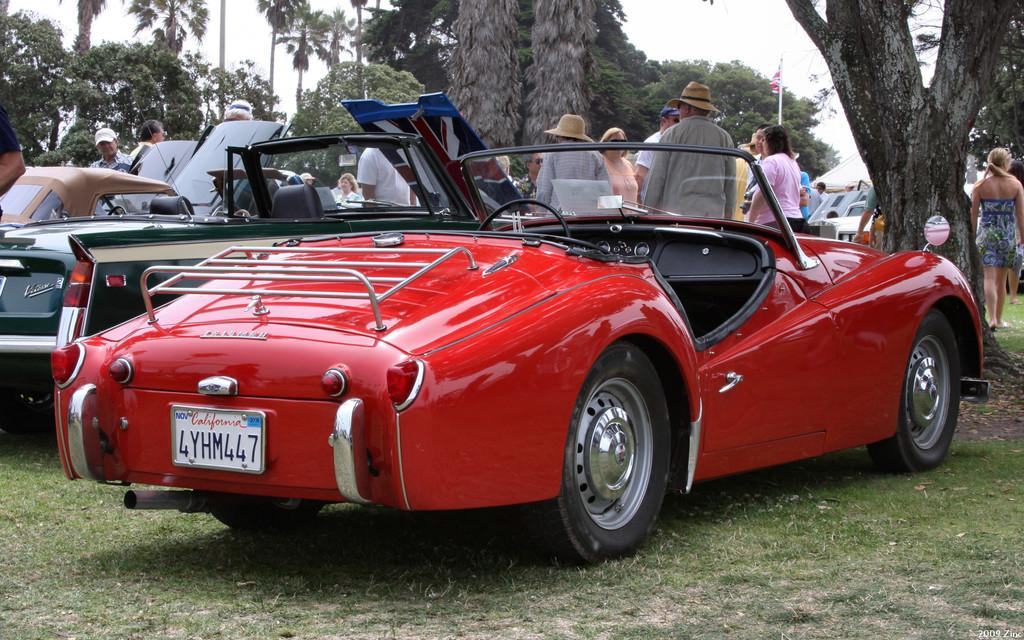What types of objects can be seen in the image? There are vehicles in the image. What else can be seen in the image besides the vehicles? There are people on the ground in the image. What can be seen in the background of the image? There are trees and the sky visible in the background of the image. Can you tell me how many beads are being used for division in the image? There is no reference to beads or division in the image; it features vehicles, people, trees, and the sky. 